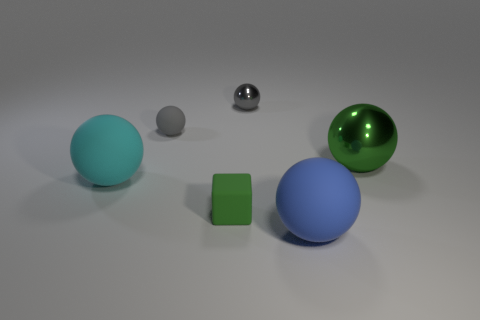The gray metal object that is the same shape as the cyan matte thing is what size?
Make the answer very short. Small. There is a small gray metal thing to the right of the cube; is it the same shape as the small rubber object on the right side of the gray rubber object?
Provide a short and direct response. No. Is the size of the cyan rubber sphere the same as the green thing that is in front of the big green thing?
Make the answer very short. No. What number of other objects are there of the same material as the blue ball?
Your answer should be compact. 3. Are there any other things that are the same shape as the tiny green object?
Make the answer very short. No. There is a large shiny object behind the green thing to the left of the small gray thing behind the tiny gray rubber object; what color is it?
Keep it short and to the point. Green. The object that is both to the left of the small metallic thing and in front of the big cyan thing has what shape?
Provide a succinct answer. Cube. The large thing that is to the left of the tiny gray object that is on the left side of the gray shiny ball is what color?
Provide a succinct answer. Cyan. The rubber thing on the left side of the rubber thing that is behind the green thing to the right of the large blue sphere is what shape?
Your answer should be compact. Sphere. There is a matte ball that is both right of the large cyan matte ball and on the left side of the large blue rubber sphere; what is its size?
Make the answer very short. Small. 